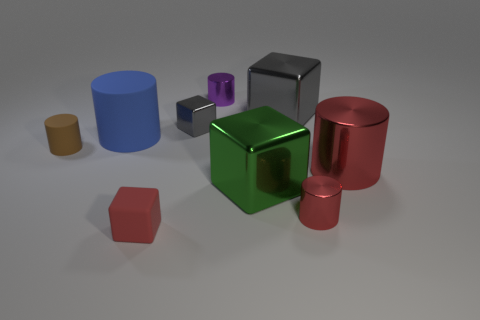Is the number of tiny blocks behind the purple cylinder less than the number of spheres?
Keep it short and to the point. No. Are there any other things that have the same shape as the big gray thing?
Provide a short and direct response. Yes. Are there any purple objects?
Keep it short and to the point. Yes. Is the number of large brown metallic cylinders less than the number of big shiny blocks?
Provide a succinct answer. Yes. What number of big red things have the same material as the big blue cylinder?
Keep it short and to the point. 0. There is a block that is the same material as the big blue thing; what color is it?
Your answer should be compact. Red. What shape is the large gray metal object?
Your response must be concise. Cube. How many cubes have the same color as the large metal cylinder?
Provide a succinct answer. 1. There is a gray shiny thing that is the same size as the green shiny thing; what shape is it?
Provide a succinct answer. Cube. Are there any purple shiny objects that have the same size as the green metal block?
Offer a terse response. No. 